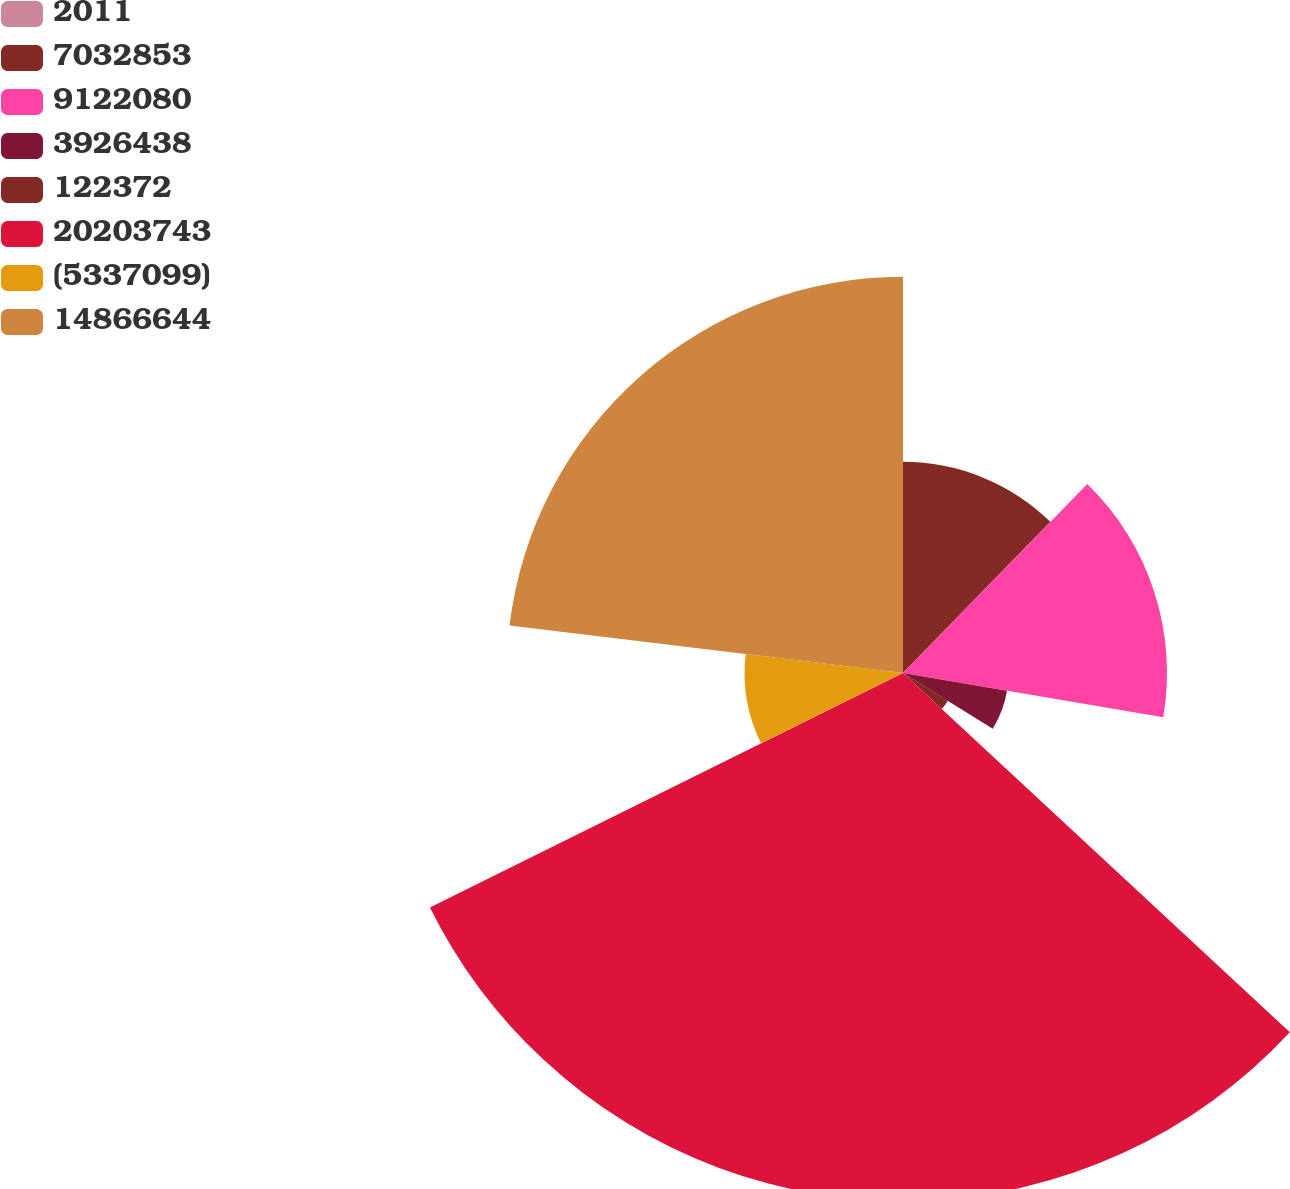Convert chart. <chart><loc_0><loc_0><loc_500><loc_500><pie_chart><fcel>2011<fcel>7032853<fcel>9122080<fcel>3926438<fcel>122372<fcel>20203743<fcel>(5337099)<fcel>14866644<nl><fcel>0.0%<fcel>12.3%<fcel>15.38%<fcel>6.15%<fcel>3.08%<fcel>30.76%<fcel>9.23%<fcel>23.09%<nl></chart> 